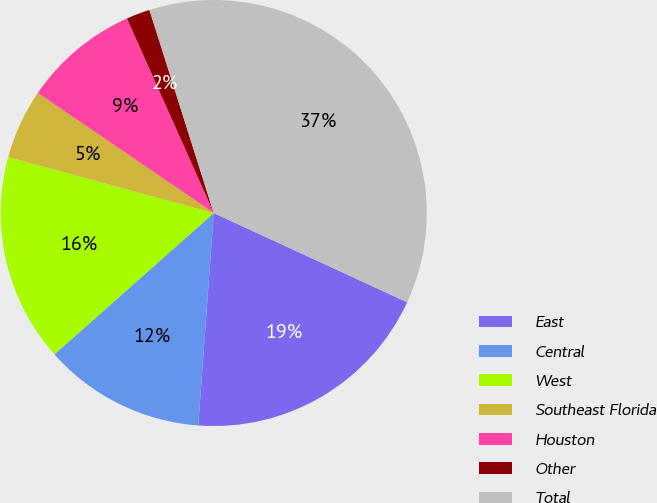Convert chart to OTSL. <chart><loc_0><loc_0><loc_500><loc_500><pie_chart><fcel>East<fcel>Central<fcel>West<fcel>Southeast Florida<fcel>Houston<fcel>Other<fcel>Total<nl><fcel>19.28%<fcel>12.29%<fcel>15.78%<fcel>5.3%<fcel>8.79%<fcel>1.8%<fcel>36.76%<nl></chart> 